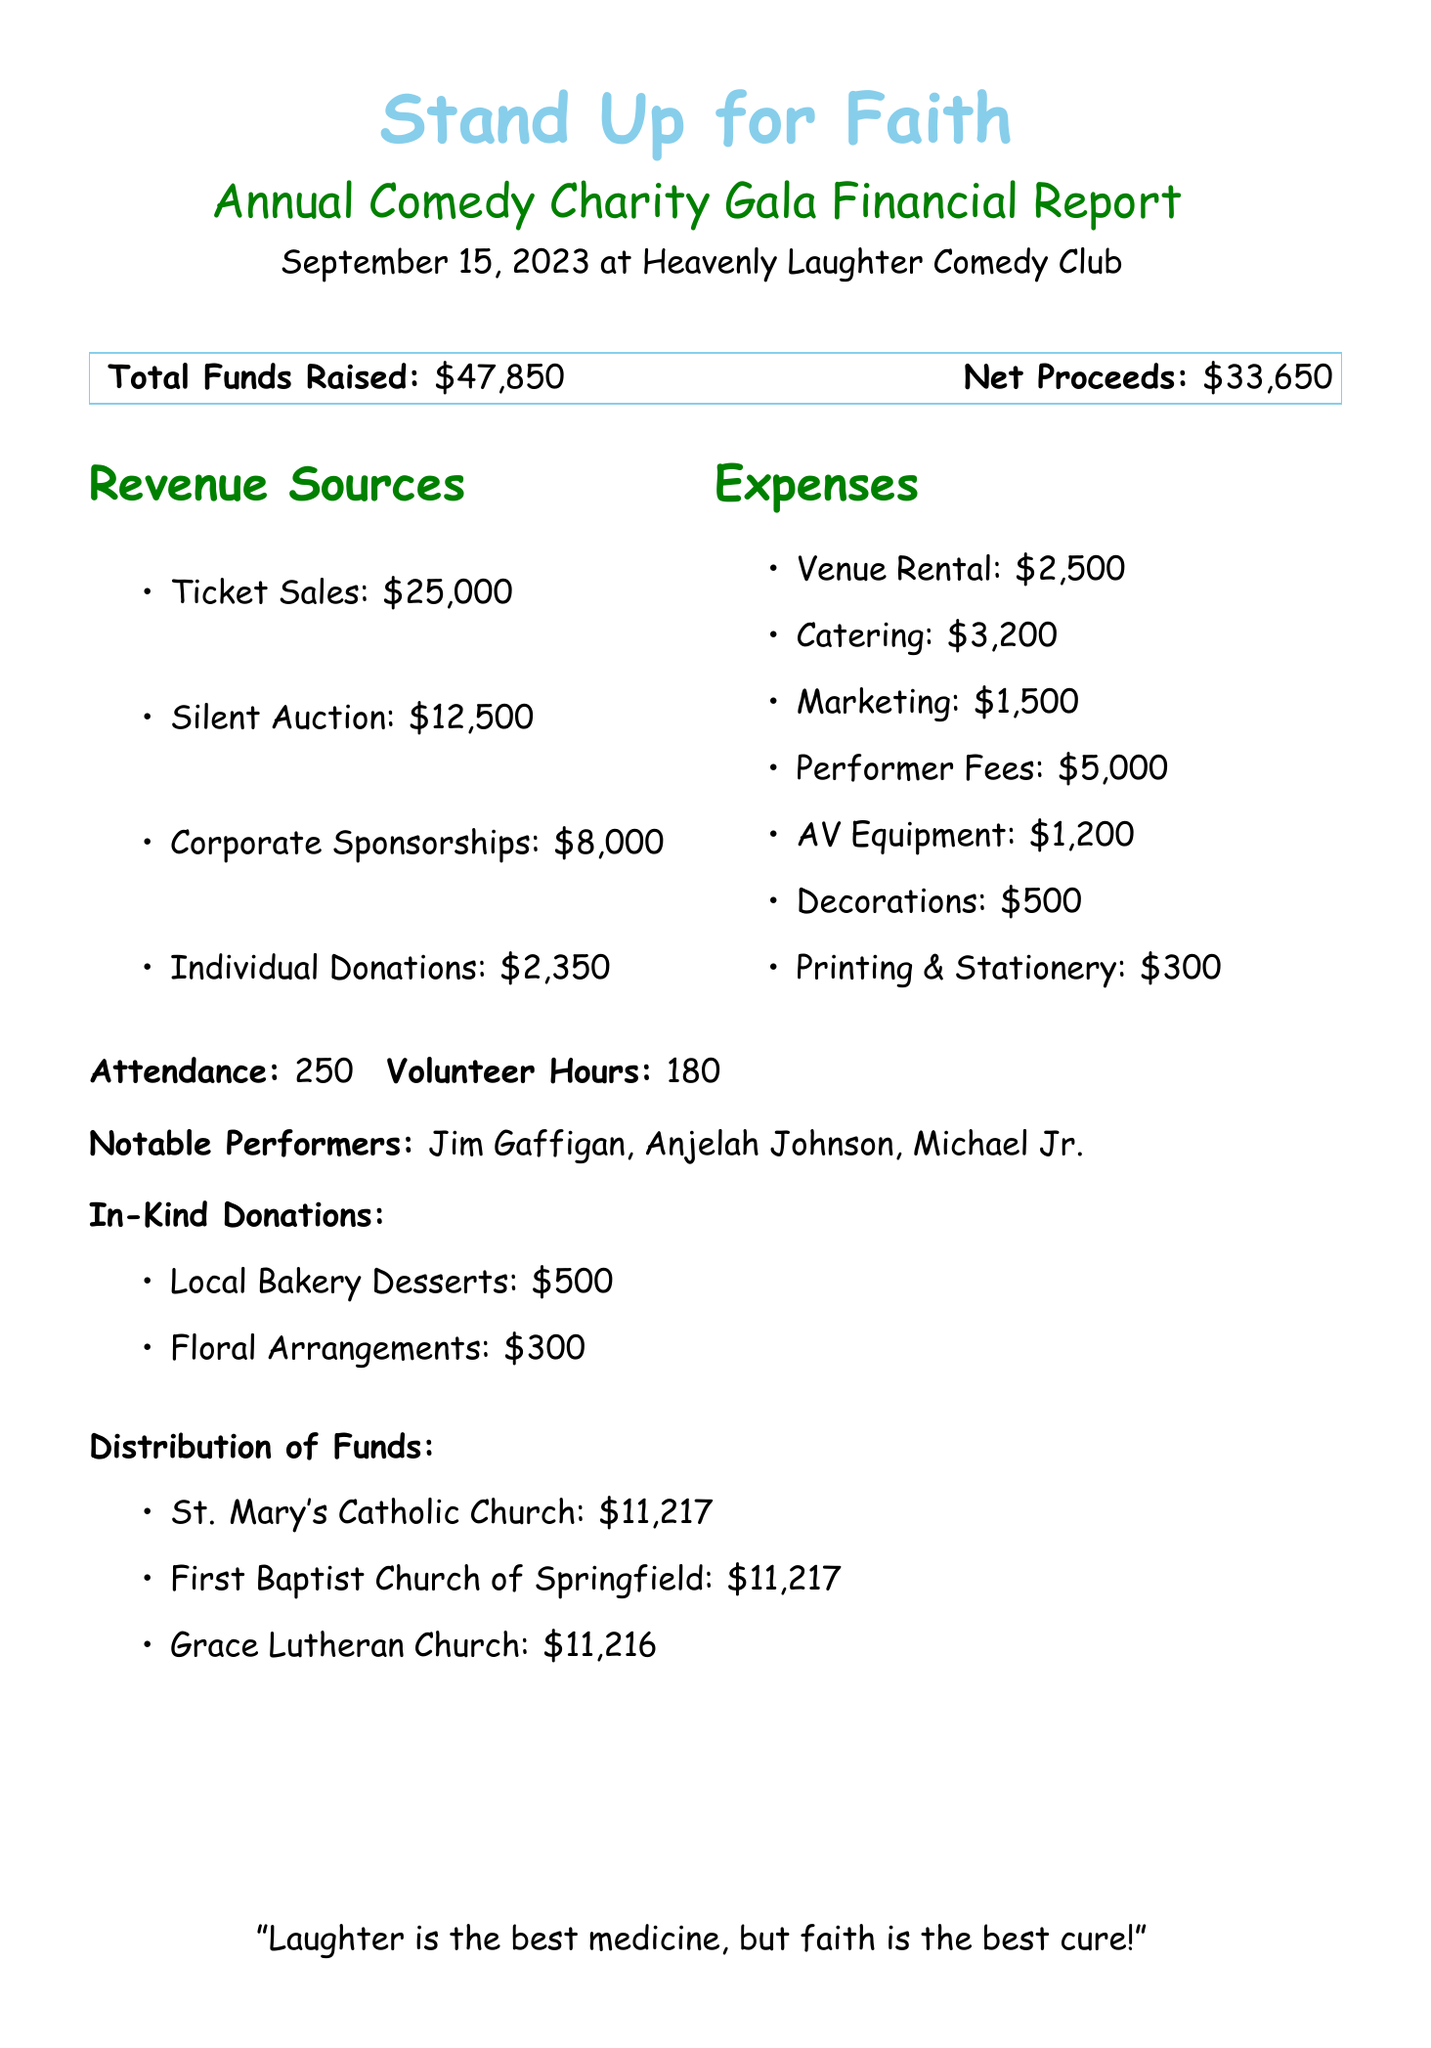What is the name of the event? The document states that the event is called "Stand Up for Faith: Annual Comedy Charity Gala."
Answer: Stand Up for Faith: Annual Comedy Charity Gala What was the date of the event? The event took place on September 15, 2023, as indicated in the document.
Answer: September 15, 2023 What was the total amount of expenses? The total expenses can be calculated by adding all the expense items listed: $2,500 + $3,200 + $1,500 + $5,000 + $1,200 + $500 + $300 = $14,200.
Answer: $14,200 Who were the notable performers? The document lists Jim Gaffigan, Anjelah Johnson, and Michael Jr. as the notable performers of the event.
Answer: Jim Gaffigan, Anjelah Johnson, Michael Jr How many churches benefited from the funds? The document mentions three churches that were beneficiaries of the fundraiser event.
Answer: Three What was the net proceeds from the event? The net proceeds from the event are stated to be $33,650 in the document.
Answer: $33,650 What was raised from ticket sales? The document indicates that ticket sales generated $25,000.
Answer: $25,000 Which church received the least amount of funds? The document shows that Grace Lutheran Church received $11,216, which is the least among the three churches listed.
Answer: Grace Lutheran Church What is the total funds raised? The total funds raised at the event is stated to be $47,850 in the document.
Answer: $47,850 